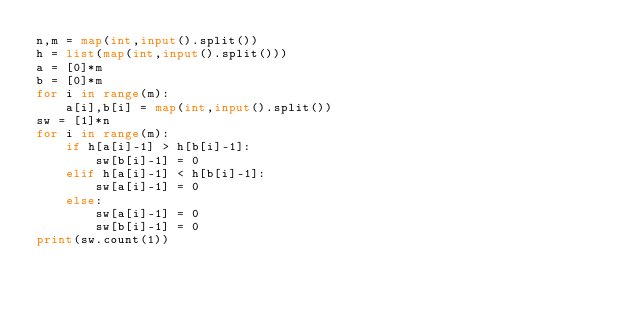<code> <loc_0><loc_0><loc_500><loc_500><_Python_>n,m = map(int,input().split())
h = list(map(int,input().split()))
a = [0]*m
b = [0]*m
for i in range(m):
    a[i],b[i] = map(int,input().split())
sw = [1]*n
for i in range(m):
    if h[a[i]-1] > h[b[i]-1]:
        sw[b[i]-1] = 0
    elif h[a[i]-1] < h[b[i]-1]:
        sw[a[i]-1] = 0
    else:
        sw[a[i]-1] = 0
        sw[b[i]-1] = 0
print(sw.count(1))</code> 